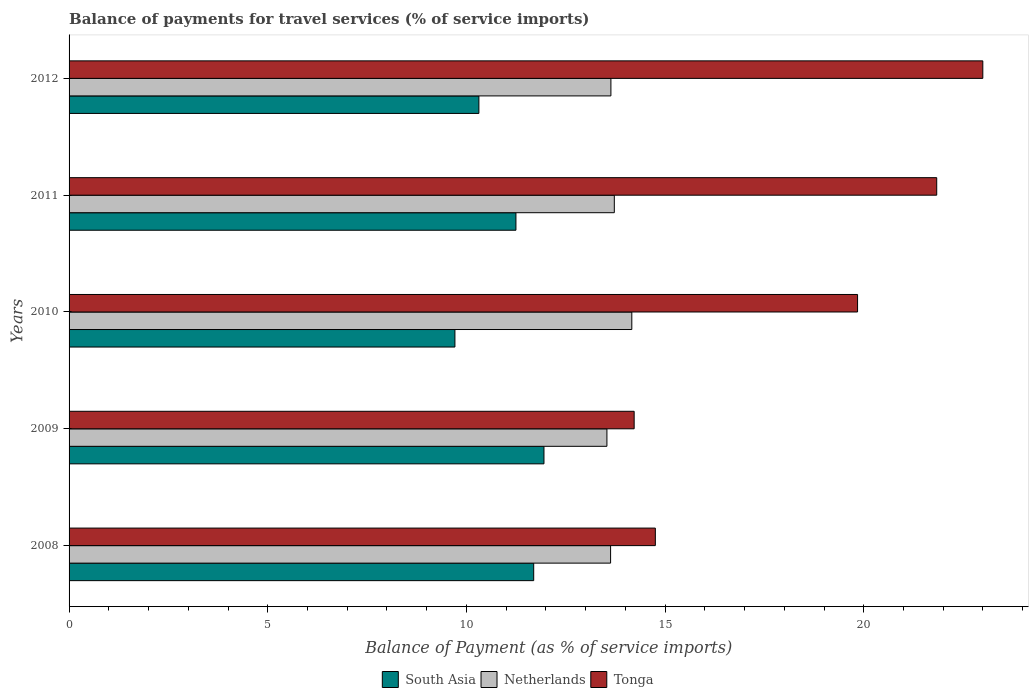How many different coloured bars are there?
Ensure brevity in your answer.  3. Are the number of bars on each tick of the Y-axis equal?
Your answer should be compact. Yes. How many bars are there on the 1st tick from the bottom?
Give a very brief answer. 3. What is the label of the 5th group of bars from the top?
Provide a succinct answer. 2008. What is the balance of payments for travel services in South Asia in 2009?
Keep it short and to the point. 11.95. Across all years, what is the maximum balance of payments for travel services in Netherlands?
Offer a terse response. 14.16. Across all years, what is the minimum balance of payments for travel services in Netherlands?
Your answer should be compact. 13.54. In which year was the balance of payments for travel services in South Asia minimum?
Provide a succinct answer. 2010. What is the total balance of payments for travel services in South Asia in the graph?
Provide a short and direct response. 54.92. What is the difference between the balance of payments for travel services in South Asia in 2010 and that in 2011?
Provide a short and direct response. -1.54. What is the difference between the balance of payments for travel services in Netherlands in 2008 and the balance of payments for travel services in Tonga in 2012?
Ensure brevity in your answer.  -9.37. What is the average balance of payments for travel services in Tonga per year?
Your response must be concise. 18.73. In the year 2010, what is the difference between the balance of payments for travel services in Netherlands and balance of payments for travel services in South Asia?
Offer a terse response. 4.45. In how many years, is the balance of payments for travel services in Tonga greater than 7 %?
Ensure brevity in your answer.  5. What is the ratio of the balance of payments for travel services in Netherlands in 2009 to that in 2011?
Ensure brevity in your answer.  0.99. Is the balance of payments for travel services in South Asia in 2010 less than that in 2011?
Make the answer very short. Yes. What is the difference between the highest and the second highest balance of payments for travel services in Netherlands?
Your answer should be very brief. 0.44. What is the difference between the highest and the lowest balance of payments for travel services in Tonga?
Your answer should be compact. 8.77. Is the sum of the balance of payments for travel services in South Asia in 2009 and 2010 greater than the maximum balance of payments for travel services in Netherlands across all years?
Provide a short and direct response. Yes. What does the 2nd bar from the top in 2008 represents?
Your answer should be very brief. Netherlands. What does the 1st bar from the bottom in 2010 represents?
Your answer should be very brief. South Asia. Is it the case that in every year, the sum of the balance of payments for travel services in South Asia and balance of payments for travel services in Netherlands is greater than the balance of payments for travel services in Tonga?
Your answer should be compact. Yes. Are all the bars in the graph horizontal?
Ensure brevity in your answer.  Yes. How many years are there in the graph?
Your response must be concise. 5. What is the difference between two consecutive major ticks on the X-axis?
Your response must be concise. 5. Are the values on the major ticks of X-axis written in scientific E-notation?
Give a very brief answer. No. Does the graph contain grids?
Keep it short and to the point. No. Where does the legend appear in the graph?
Provide a succinct answer. Bottom center. How are the legend labels stacked?
Offer a terse response. Horizontal. What is the title of the graph?
Ensure brevity in your answer.  Balance of payments for travel services (% of service imports). Does "Netherlands" appear as one of the legend labels in the graph?
Keep it short and to the point. Yes. What is the label or title of the X-axis?
Provide a short and direct response. Balance of Payment (as % of service imports). What is the label or title of the Y-axis?
Your answer should be very brief. Years. What is the Balance of Payment (as % of service imports) of South Asia in 2008?
Keep it short and to the point. 11.69. What is the Balance of Payment (as % of service imports) of Netherlands in 2008?
Give a very brief answer. 13.63. What is the Balance of Payment (as % of service imports) of Tonga in 2008?
Provide a succinct answer. 14.75. What is the Balance of Payment (as % of service imports) of South Asia in 2009?
Provide a short and direct response. 11.95. What is the Balance of Payment (as % of service imports) in Netherlands in 2009?
Give a very brief answer. 13.54. What is the Balance of Payment (as % of service imports) of Tonga in 2009?
Make the answer very short. 14.22. What is the Balance of Payment (as % of service imports) in South Asia in 2010?
Keep it short and to the point. 9.71. What is the Balance of Payment (as % of service imports) in Netherlands in 2010?
Give a very brief answer. 14.16. What is the Balance of Payment (as % of service imports) of Tonga in 2010?
Keep it short and to the point. 19.84. What is the Balance of Payment (as % of service imports) in South Asia in 2011?
Give a very brief answer. 11.25. What is the Balance of Payment (as % of service imports) in Netherlands in 2011?
Keep it short and to the point. 13.72. What is the Balance of Payment (as % of service imports) of Tonga in 2011?
Ensure brevity in your answer.  21.84. What is the Balance of Payment (as % of service imports) in South Asia in 2012?
Keep it short and to the point. 10.31. What is the Balance of Payment (as % of service imports) in Netherlands in 2012?
Offer a terse response. 13.64. What is the Balance of Payment (as % of service imports) of Tonga in 2012?
Offer a very short reply. 23. Across all years, what is the maximum Balance of Payment (as % of service imports) of South Asia?
Give a very brief answer. 11.95. Across all years, what is the maximum Balance of Payment (as % of service imports) in Netherlands?
Give a very brief answer. 14.16. Across all years, what is the maximum Balance of Payment (as % of service imports) of Tonga?
Your response must be concise. 23. Across all years, what is the minimum Balance of Payment (as % of service imports) of South Asia?
Give a very brief answer. 9.71. Across all years, what is the minimum Balance of Payment (as % of service imports) of Netherlands?
Offer a terse response. 13.54. Across all years, what is the minimum Balance of Payment (as % of service imports) in Tonga?
Provide a succinct answer. 14.22. What is the total Balance of Payment (as % of service imports) of South Asia in the graph?
Offer a very short reply. 54.92. What is the total Balance of Payment (as % of service imports) of Netherlands in the graph?
Make the answer very short. 68.68. What is the total Balance of Payment (as % of service imports) of Tonga in the graph?
Provide a short and direct response. 93.65. What is the difference between the Balance of Payment (as % of service imports) of South Asia in 2008 and that in 2009?
Offer a terse response. -0.26. What is the difference between the Balance of Payment (as % of service imports) in Netherlands in 2008 and that in 2009?
Ensure brevity in your answer.  0.09. What is the difference between the Balance of Payment (as % of service imports) of Tonga in 2008 and that in 2009?
Give a very brief answer. 0.53. What is the difference between the Balance of Payment (as % of service imports) of South Asia in 2008 and that in 2010?
Give a very brief answer. 1.98. What is the difference between the Balance of Payment (as % of service imports) of Netherlands in 2008 and that in 2010?
Keep it short and to the point. -0.53. What is the difference between the Balance of Payment (as % of service imports) of Tonga in 2008 and that in 2010?
Make the answer very short. -5.09. What is the difference between the Balance of Payment (as % of service imports) in South Asia in 2008 and that in 2011?
Ensure brevity in your answer.  0.45. What is the difference between the Balance of Payment (as % of service imports) in Netherlands in 2008 and that in 2011?
Give a very brief answer. -0.09. What is the difference between the Balance of Payment (as % of service imports) in Tonga in 2008 and that in 2011?
Ensure brevity in your answer.  -7.08. What is the difference between the Balance of Payment (as % of service imports) of South Asia in 2008 and that in 2012?
Your answer should be very brief. 1.38. What is the difference between the Balance of Payment (as % of service imports) in Netherlands in 2008 and that in 2012?
Make the answer very short. -0.01. What is the difference between the Balance of Payment (as % of service imports) of Tonga in 2008 and that in 2012?
Keep it short and to the point. -8.24. What is the difference between the Balance of Payment (as % of service imports) in South Asia in 2009 and that in 2010?
Offer a very short reply. 2.24. What is the difference between the Balance of Payment (as % of service imports) in Netherlands in 2009 and that in 2010?
Your answer should be compact. -0.63. What is the difference between the Balance of Payment (as % of service imports) of Tonga in 2009 and that in 2010?
Give a very brief answer. -5.62. What is the difference between the Balance of Payment (as % of service imports) in South Asia in 2009 and that in 2011?
Your response must be concise. 0.71. What is the difference between the Balance of Payment (as % of service imports) in Netherlands in 2009 and that in 2011?
Your answer should be compact. -0.19. What is the difference between the Balance of Payment (as % of service imports) in Tonga in 2009 and that in 2011?
Provide a short and direct response. -7.61. What is the difference between the Balance of Payment (as % of service imports) of South Asia in 2009 and that in 2012?
Give a very brief answer. 1.64. What is the difference between the Balance of Payment (as % of service imports) of Netherlands in 2009 and that in 2012?
Provide a succinct answer. -0.1. What is the difference between the Balance of Payment (as % of service imports) in Tonga in 2009 and that in 2012?
Keep it short and to the point. -8.77. What is the difference between the Balance of Payment (as % of service imports) of South Asia in 2010 and that in 2011?
Your response must be concise. -1.54. What is the difference between the Balance of Payment (as % of service imports) of Netherlands in 2010 and that in 2011?
Offer a terse response. 0.44. What is the difference between the Balance of Payment (as % of service imports) in Tonga in 2010 and that in 2011?
Your answer should be very brief. -1.99. What is the difference between the Balance of Payment (as % of service imports) in South Asia in 2010 and that in 2012?
Provide a succinct answer. -0.6. What is the difference between the Balance of Payment (as % of service imports) of Netherlands in 2010 and that in 2012?
Offer a terse response. 0.53. What is the difference between the Balance of Payment (as % of service imports) in Tonga in 2010 and that in 2012?
Ensure brevity in your answer.  -3.15. What is the difference between the Balance of Payment (as % of service imports) in South Asia in 2011 and that in 2012?
Your answer should be very brief. 0.93. What is the difference between the Balance of Payment (as % of service imports) of Netherlands in 2011 and that in 2012?
Make the answer very short. 0.09. What is the difference between the Balance of Payment (as % of service imports) of Tonga in 2011 and that in 2012?
Your response must be concise. -1.16. What is the difference between the Balance of Payment (as % of service imports) of South Asia in 2008 and the Balance of Payment (as % of service imports) of Netherlands in 2009?
Your answer should be compact. -1.84. What is the difference between the Balance of Payment (as % of service imports) in South Asia in 2008 and the Balance of Payment (as % of service imports) in Tonga in 2009?
Provide a short and direct response. -2.53. What is the difference between the Balance of Payment (as % of service imports) of Netherlands in 2008 and the Balance of Payment (as % of service imports) of Tonga in 2009?
Ensure brevity in your answer.  -0.59. What is the difference between the Balance of Payment (as % of service imports) of South Asia in 2008 and the Balance of Payment (as % of service imports) of Netherlands in 2010?
Offer a very short reply. -2.47. What is the difference between the Balance of Payment (as % of service imports) of South Asia in 2008 and the Balance of Payment (as % of service imports) of Tonga in 2010?
Your answer should be compact. -8.15. What is the difference between the Balance of Payment (as % of service imports) of Netherlands in 2008 and the Balance of Payment (as % of service imports) of Tonga in 2010?
Your answer should be very brief. -6.22. What is the difference between the Balance of Payment (as % of service imports) in South Asia in 2008 and the Balance of Payment (as % of service imports) in Netherlands in 2011?
Give a very brief answer. -2.03. What is the difference between the Balance of Payment (as % of service imports) in South Asia in 2008 and the Balance of Payment (as % of service imports) in Tonga in 2011?
Give a very brief answer. -10.14. What is the difference between the Balance of Payment (as % of service imports) in Netherlands in 2008 and the Balance of Payment (as % of service imports) in Tonga in 2011?
Provide a succinct answer. -8.21. What is the difference between the Balance of Payment (as % of service imports) of South Asia in 2008 and the Balance of Payment (as % of service imports) of Netherlands in 2012?
Provide a short and direct response. -1.94. What is the difference between the Balance of Payment (as % of service imports) in South Asia in 2008 and the Balance of Payment (as % of service imports) in Tonga in 2012?
Provide a short and direct response. -11.3. What is the difference between the Balance of Payment (as % of service imports) of Netherlands in 2008 and the Balance of Payment (as % of service imports) of Tonga in 2012?
Offer a terse response. -9.37. What is the difference between the Balance of Payment (as % of service imports) of South Asia in 2009 and the Balance of Payment (as % of service imports) of Netherlands in 2010?
Offer a very short reply. -2.21. What is the difference between the Balance of Payment (as % of service imports) of South Asia in 2009 and the Balance of Payment (as % of service imports) of Tonga in 2010?
Ensure brevity in your answer.  -7.89. What is the difference between the Balance of Payment (as % of service imports) in Netherlands in 2009 and the Balance of Payment (as % of service imports) in Tonga in 2010?
Ensure brevity in your answer.  -6.31. What is the difference between the Balance of Payment (as % of service imports) in South Asia in 2009 and the Balance of Payment (as % of service imports) in Netherlands in 2011?
Your answer should be very brief. -1.77. What is the difference between the Balance of Payment (as % of service imports) in South Asia in 2009 and the Balance of Payment (as % of service imports) in Tonga in 2011?
Offer a terse response. -9.88. What is the difference between the Balance of Payment (as % of service imports) in Netherlands in 2009 and the Balance of Payment (as % of service imports) in Tonga in 2011?
Keep it short and to the point. -8.3. What is the difference between the Balance of Payment (as % of service imports) of South Asia in 2009 and the Balance of Payment (as % of service imports) of Netherlands in 2012?
Provide a short and direct response. -1.68. What is the difference between the Balance of Payment (as % of service imports) in South Asia in 2009 and the Balance of Payment (as % of service imports) in Tonga in 2012?
Give a very brief answer. -11.04. What is the difference between the Balance of Payment (as % of service imports) in Netherlands in 2009 and the Balance of Payment (as % of service imports) in Tonga in 2012?
Your answer should be very brief. -9.46. What is the difference between the Balance of Payment (as % of service imports) of South Asia in 2010 and the Balance of Payment (as % of service imports) of Netherlands in 2011?
Give a very brief answer. -4.01. What is the difference between the Balance of Payment (as % of service imports) in South Asia in 2010 and the Balance of Payment (as % of service imports) in Tonga in 2011?
Your answer should be compact. -12.13. What is the difference between the Balance of Payment (as % of service imports) in Netherlands in 2010 and the Balance of Payment (as % of service imports) in Tonga in 2011?
Ensure brevity in your answer.  -7.67. What is the difference between the Balance of Payment (as % of service imports) in South Asia in 2010 and the Balance of Payment (as % of service imports) in Netherlands in 2012?
Give a very brief answer. -3.93. What is the difference between the Balance of Payment (as % of service imports) of South Asia in 2010 and the Balance of Payment (as % of service imports) of Tonga in 2012?
Give a very brief answer. -13.29. What is the difference between the Balance of Payment (as % of service imports) of Netherlands in 2010 and the Balance of Payment (as % of service imports) of Tonga in 2012?
Offer a very short reply. -8.83. What is the difference between the Balance of Payment (as % of service imports) of South Asia in 2011 and the Balance of Payment (as % of service imports) of Netherlands in 2012?
Your answer should be very brief. -2.39. What is the difference between the Balance of Payment (as % of service imports) of South Asia in 2011 and the Balance of Payment (as % of service imports) of Tonga in 2012?
Your answer should be compact. -11.75. What is the difference between the Balance of Payment (as % of service imports) of Netherlands in 2011 and the Balance of Payment (as % of service imports) of Tonga in 2012?
Give a very brief answer. -9.27. What is the average Balance of Payment (as % of service imports) in South Asia per year?
Offer a terse response. 10.98. What is the average Balance of Payment (as % of service imports) in Netherlands per year?
Ensure brevity in your answer.  13.74. What is the average Balance of Payment (as % of service imports) of Tonga per year?
Provide a short and direct response. 18.73. In the year 2008, what is the difference between the Balance of Payment (as % of service imports) in South Asia and Balance of Payment (as % of service imports) in Netherlands?
Keep it short and to the point. -1.93. In the year 2008, what is the difference between the Balance of Payment (as % of service imports) in South Asia and Balance of Payment (as % of service imports) in Tonga?
Keep it short and to the point. -3.06. In the year 2008, what is the difference between the Balance of Payment (as % of service imports) in Netherlands and Balance of Payment (as % of service imports) in Tonga?
Offer a very short reply. -1.13. In the year 2009, what is the difference between the Balance of Payment (as % of service imports) in South Asia and Balance of Payment (as % of service imports) in Netherlands?
Provide a succinct answer. -1.58. In the year 2009, what is the difference between the Balance of Payment (as % of service imports) in South Asia and Balance of Payment (as % of service imports) in Tonga?
Provide a short and direct response. -2.27. In the year 2009, what is the difference between the Balance of Payment (as % of service imports) in Netherlands and Balance of Payment (as % of service imports) in Tonga?
Provide a succinct answer. -0.69. In the year 2010, what is the difference between the Balance of Payment (as % of service imports) in South Asia and Balance of Payment (as % of service imports) in Netherlands?
Your answer should be compact. -4.45. In the year 2010, what is the difference between the Balance of Payment (as % of service imports) of South Asia and Balance of Payment (as % of service imports) of Tonga?
Offer a very short reply. -10.13. In the year 2010, what is the difference between the Balance of Payment (as % of service imports) in Netherlands and Balance of Payment (as % of service imports) in Tonga?
Your response must be concise. -5.68. In the year 2011, what is the difference between the Balance of Payment (as % of service imports) in South Asia and Balance of Payment (as % of service imports) in Netherlands?
Provide a short and direct response. -2.48. In the year 2011, what is the difference between the Balance of Payment (as % of service imports) in South Asia and Balance of Payment (as % of service imports) in Tonga?
Keep it short and to the point. -10.59. In the year 2011, what is the difference between the Balance of Payment (as % of service imports) of Netherlands and Balance of Payment (as % of service imports) of Tonga?
Give a very brief answer. -8.11. In the year 2012, what is the difference between the Balance of Payment (as % of service imports) in South Asia and Balance of Payment (as % of service imports) in Netherlands?
Provide a succinct answer. -3.32. In the year 2012, what is the difference between the Balance of Payment (as % of service imports) of South Asia and Balance of Payment (as % of service imports) of Tonga?
Offer a very short reply. -12.68. In the year 2012, what is the difference between the Balance of Payment (as % of service imports) of Netherlands and Balance of Payment (as % of service imports) of Tonga?
Give a very brief answer. -9.36. What is the ratio of the Balance of Payment (as % of service imports) in South Asia in 2008 to that in 2009?
Provide a short and direct response. 0.98. What is the ratio of the Balance of Payment (as % of service imports) of Netherlands in 2008 to that in 2009?
Your response must be concise. 1.01. What is the ratio of the Balance of Payment (as % of service imports) in Tonga in 2008 to that in 2009?
Offer a very short reply. 1.04. What is the ratio of the Balance of Payment (as % of service imports) in South Asia in 2008 to that in 2010?
Your answer should be very brief. 1.2. What is the ratio of the Balance of Payment (as % of service imports) in Netherlands in 2008 to that in 2010?
Your answer should be very brief. 0.96. What is the ratio of the Balance of Payment (as % of service imports) in Tonga in 2008 to that in 2010?
Provide a short and direct response. 0.74. What is the ratio of the Balance of Payment (as % of service imports) in South Asia in 2008 to that in 2011?
Provide a succinct answer. 1.04. What is the ratio of the Balance of Payment (as % of service imports) in Netherlands in 2008 to that in 2011?
Offer a very short reply. 0.99. What is the ratio of the Balance of Payment (as % of service imports) in Tonga in 2008 to that in 2011?
Provide a short and direct response. 0.68. What is the ratio of the Balance of Payment (as % of service imports) of South Asia in 2008 to that in 2012?
Provide a short and direct response. 1.13. What is the ratio of the Balance of Payment (as % of service imports) of Netherlands in 2008 to that in 2012?
Offer a terse response. 1. What is the ratio of the Balance of Payment (as % of service imports) of Tonga in 2008 to that in 2012?
Ensure brevity in your answer.  0.64. What is the ratio of the Balance of Payment (as % of service imports) in South Asia in 2009 to that in 2010?
Your response must be concise. 1.23. What is the ratio of the Balance of Payment (as % of service imports) of Netherlands in 2009 to that in 2010?
Provide a succinct answer. 0.96. What is the ratio of the Balance of Payment (as % of service imports) of Tonga in 2009 to that in 2010?
Your response must be concise. 0.72. What is the ratio of the Balance of Payment (as % of service imports) in South Asia in 2009 to that in 2011?
Offer a very short reply. 1.06. What is the ratio of the Balance of Payment (as % of service imports) of Netherlands in 2009 to that in 2011?
Your answer should be compact. 0.99. What is the ratio of the Balance of Payment (as % of service imports) of Tonga in 2009 to that in 2011?
Ensure brevity in your answer.  0.65. What is the ratio of the Balance of Payment (as % of service imports) of South Asia in 2009 to that in 2012?
Offer a terse response. 1.16. What is the ratio of the Balance of Payment (as % of service imports) in Netherlands in 2009 to that in 2012?
Your answer should be compact. 0.99. What is the ratio of the Balance of Payment (as % of service imports) of Tonga in 2009 to that in 2012?
Provide a short and direct response. 0.62. What is the ratio of the Balance of Payment (as % of service imports) of South Asia in 2010 to that in 2011?
Your answer should be compact. 0.86. What is the ratio of the Balance of Payment (as % of service imports) of Netherlands in 2010 to that in 2011?
Your answer should be compact. 1.03. What is the ratio of the Balance of Payment (as % of service imports) of Tonga in 2010 to that in 2011?
Your response must be concise. 0.91. What is the ratio of the Balance of Payment (as % of service imports) in South Asia in 2010 to that in 2012?
Your answer should be compact. 0.94. What is the ratio of the Balance of Payment (as % of service imports) in Netherlands in 2010 to that in 2012?
Provide a succinct answer. 1.04. What is the ratio of the Balance of Payment (as % of service imports) in Tonga in 2010 to that in 2012?
Give a very brief answer. 0.86. What is the ratio of the Balance of Payment (as % of service imports) in South Asia in 2011 to that in 2012?
Make the answer very short. 1.09. What is the ratio of the Balance of Payment (as % of service imports) in Netherlands in 2011 to that in 2012?
Ensure brevity in your answer.  1.01. What is the ratio of the Balance of Payment (as % of service imports) in Tonga in 2011 to that in 2012?
Your answer should be very brief. 0.95. What is the difference between the highest and the second highest Balance of Payment (as % of service imports) of South Asia?
Your answer should be very brief. 0.26. What is the difference between the highest and the second highest Balance of Payment (as % of service imports) of Netherlands?
Your answer should be compact. 0.44. What is the difference between the highest and the second highest Balance of Payment (as % of service imports) in Tonga?
Make the answer very short. 1.16. What is the difference between the highest and the lowest Balance of Payment (as % of service imports) in South Asia?
Offer a very short reply. 2.24. What is the difference between the highest and the lowest Balance of Payment (as % of service imports) of Netherlands?
Provide a succinct answer. 0.63. What is the difference between the highest and the lowest Balance of Payment (as % of service imports) in Tonga?
Ensure brevity in your answer.  8.77. 